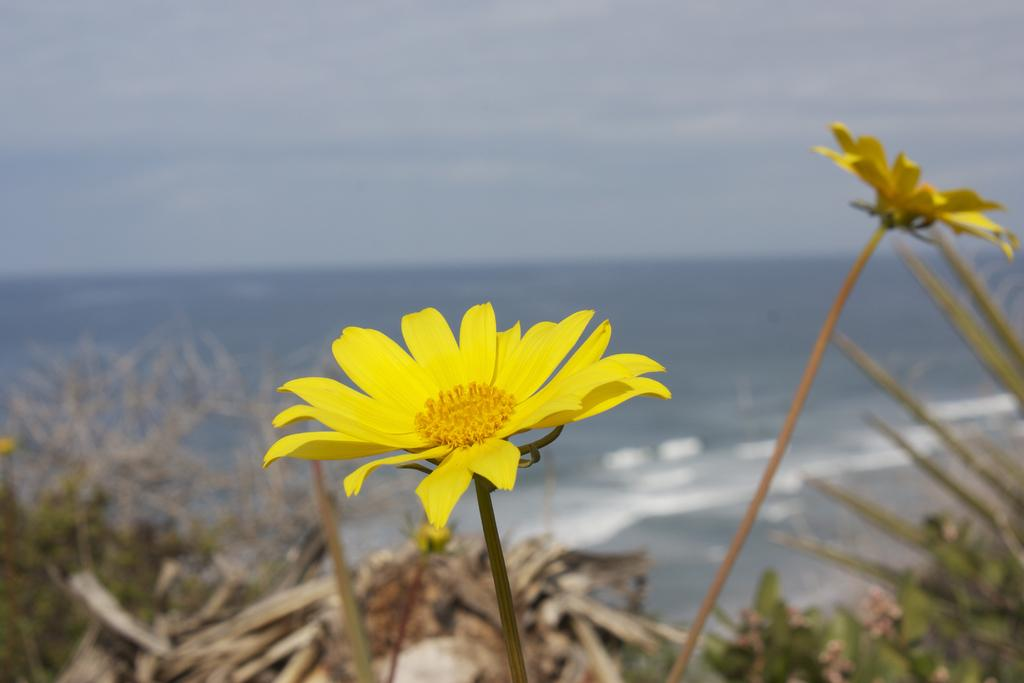How many yellow flowers can be seen in the image? There are two yellow flowers in the image. What are the flowers attached to? The flowers are on plants. Are there any other plants visible in the image? Yes, there are other plants visible in the image. What can be seen in the background of the image? The ocean is present in the background of the image. What type of goose can be seen interacting with the yellow flowers in the image? There is no goose present in the image; it only features yellow flowers on plants and other plants, with the ocean in the background. 